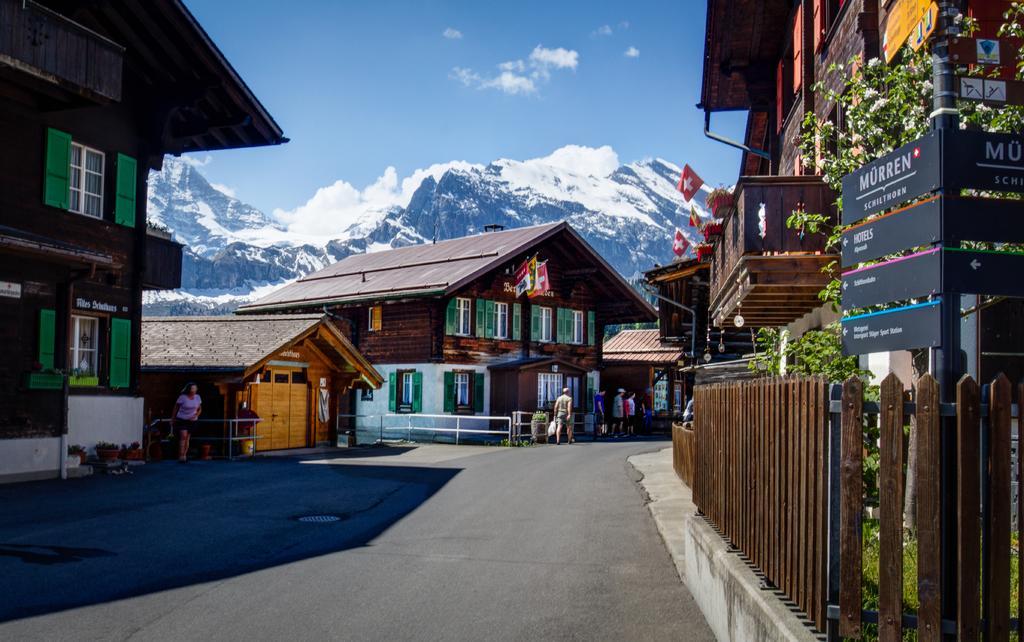Describe this image in one or two sentences. In this image I can see the road, the railing, a pole with few words to it, few persons standing and few buildings on both sides of the road. I can see few flags and in the background I can see few mountains, some snow on the mountains and the sky. 